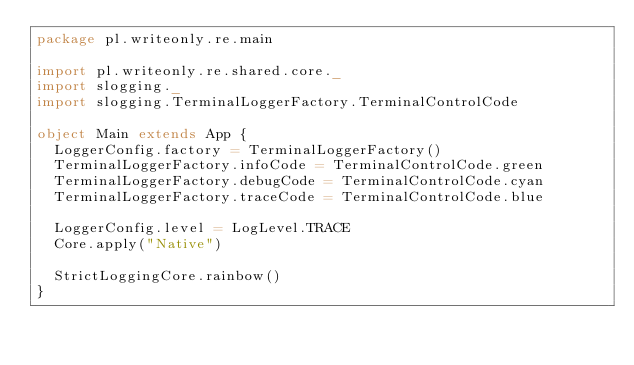Convert code to text. <code><loc_0><loc_0><loc_500><loc_500><_Scala_>package pl.writeonly.re.main

import pl.writeonly.re.shared.core._
import slogging._
import slogging.TerminalLoggerFactory.TerminalControlCode

object Main extends App {
  LoggerConfig.factory = TerminalLoggerFactory()
  TerminalLoggerFactory.infoCode = TerminalControlCode.green
  TerminalLoggerFactory.debugCode = TerminalControlCode.cyan
  TerminalLoggerFactory.traceCode = TerminalControlCode.blue

  LoggerConfig.level = LogLevel.TRACE
  Core.apply("Native")

  StrictLoggingCore.rainbow()
}
</code> 